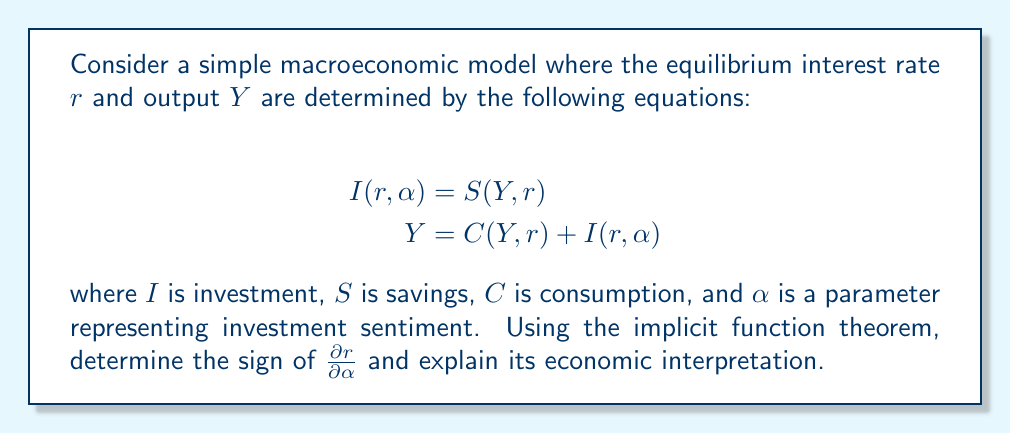Could you help me with this problem? Let's approach this step-by-step:

1) First, we need to set up our system of equations in the form $F(x, \alpha) = 0$, where $x = (r, Y)$:

   $$F_1(r, Y, \alpha) = I(r, \alpha) - S(Y, r) = 0$$
   $$F_2(r, Y, \alpha) = Y - C(Y, r) - I(r, \alpha) = 0$$

2) The implicit function theorem states that if the Jacobian matrix of $F$ with respect to $(r, Y)$ is invertible, then we can express $r$ and $Y$ as functions of $\alpha$ in a neighborhood of the equilibrium point.

3) Let's compute the Jacobian matrix:

   $$J = \begin{bmatrix}
   \frac{\partial F_1}{\partial r} & \frac{\partial F_1}{\partial Y} \\
   \frac{\partial F_2}{\partial r} & \frac{\partial F_2}{\partial Y}
   \end{bmatrix} = \begin{bmatrix}
   I_r - S_r & -S_Y \\
   -C_r - I_r & 1 - C_Y
   \end{bmatrix}$$

4) Now, we can use the implicit function theorem to find $\frac{\partial r}{\partial \alpha}$:

   $$\begin{bmatrix}
   \frac{\partial r}{\partial \alpha} \\
   \frac{\partial Y}{\partial \alpha}
   \end{bmatrix} = -J^{-1} \begin{bmatrix}
   \frac{\partial F_1}{\partial \alpha} \\
   \frac{\partial F_2}{\partial \alpha}
   \end{bmatrix} = -J^{-1} \begin{bmatrix}
   I_\alpha \\
   -I_\alpha
   \end{bmatrix}$$

5) Using Cramer's rule, we can express $\frac{\partial r}{\partial \alpha}$ as:

   $$\frac{\partial r}{\partial \alpha} = \frac{I_\alpha(1-C_Y) + I_\alpha S_Y}{|J|}$$

   where $|J|$ is the determinant of the Jacobian matrix.

6) Typically, we assume $0 < C_Y < 1$ (marginal propensity to consume is positive but less than 1), $S_Y > 0$ (savings increase with income), and $I_\alpha > 0$ (investment increases with positive sentiment).

7) Given these assumptions, the numerator is positive. If we assume the equilibrium is stable, then $|J| > 0$.

8) Therefore, $\frac{\partial r}{\partial \alpha} > 0$.

Economically, this means that as investment sentiment improves (α increases), the equilibrium interest rate rises. This is because increased investment demand puts upward pressure on interest rates in the loanable funds market.
Answer: $\frac{\partial r}{\partial \alpha} > 0$ 